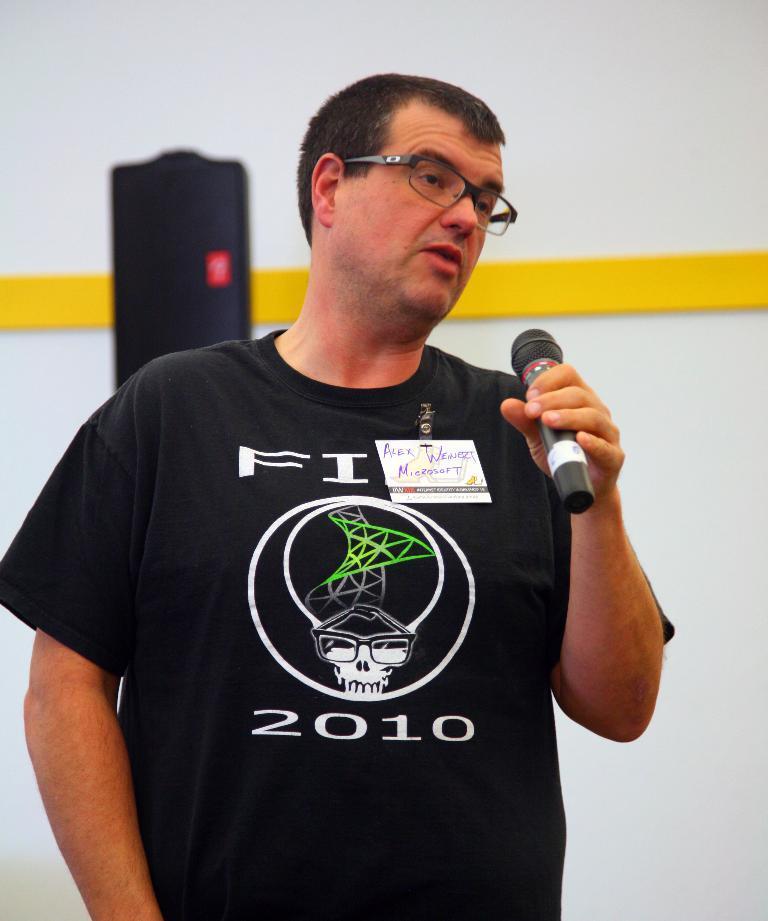Describe this image in one or two sentences. In this image I can see a person standing,wearing spectacles and holding microphone. And at the background I can see a wall. 